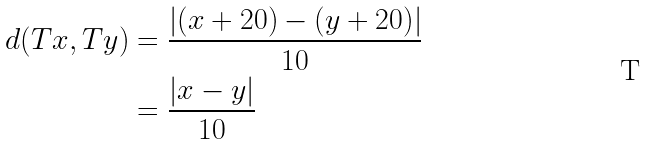<formula> <loc_0><loc_0><loc_500><loc_500>d ( T x , T y ) & = \frac { | ( x + 2 0 ) - ( y + 2 0 ) | } { 1 0 } \\ & = \frac { | x - y | } { 1 0 } \\</formula> 